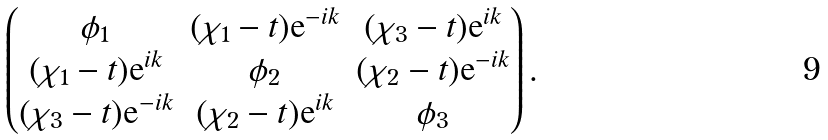Convert formula to latex. <formula><loc_0><loc_0><loc_500><loc_500>\begin{pmatrix} \phi _ { 1 } & ( \chi _ { 1 } - t ) { \text {e} } ^ { - i k } & ( \chi _ { 3 } - t ) { \text {e} } ^ { i k } \\ ( \chi _ { 1 } - t ) { \text {e} } ^ { i k } & \phi _ { 2 } & ( \chi _ { 2 } - t ) { \text {e} } ^ { - i k } \\ ( \chi _ { 3 } - t ) { \text {e} } ^ { - i k } & ( \chi _ { 2 } - t ) { \text {e} } ^ { i k } & \phi _ { 3 } \end{pmatrix} .</formula> 